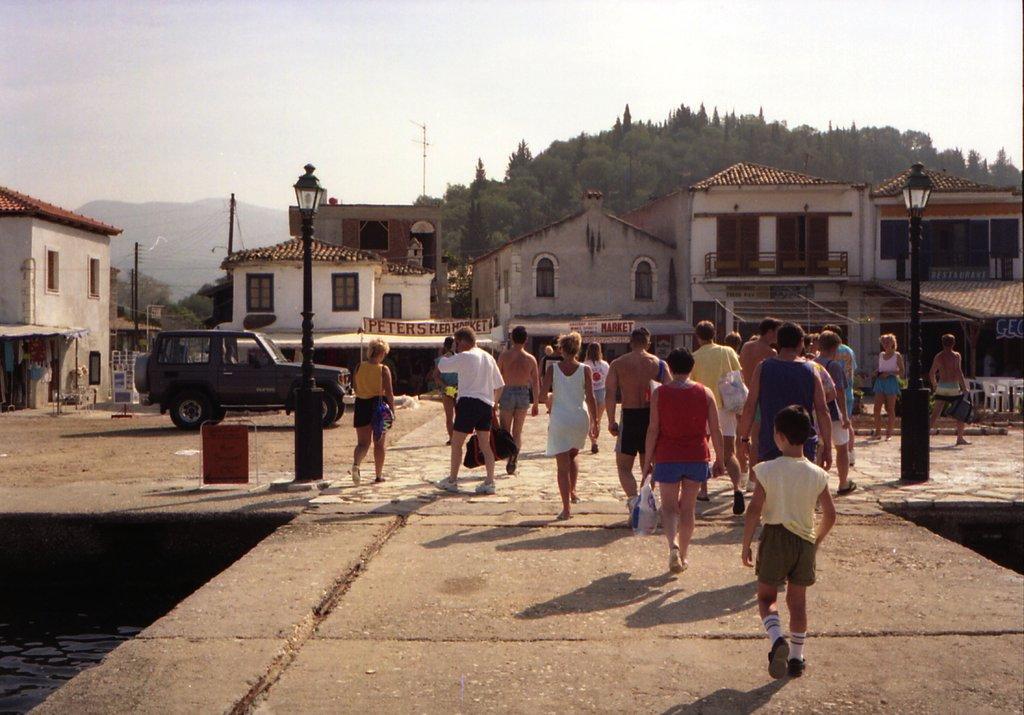Describe this image in one or two sentences. In this image there are few people on the path. In the background there are buildings, banners, chairs, cars, trees are there. These are street lights. Here we can see hills. The sky is clear. 